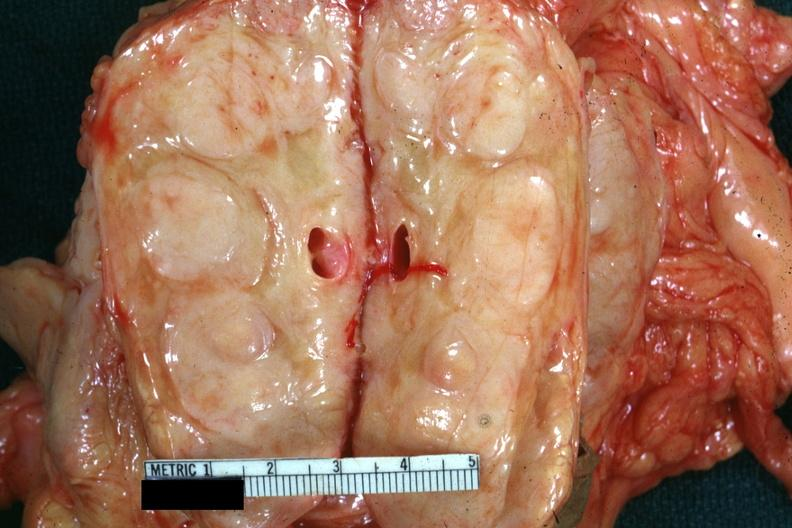what is present?
Answer the question using a single word or phrase. Malignant lymphoma 